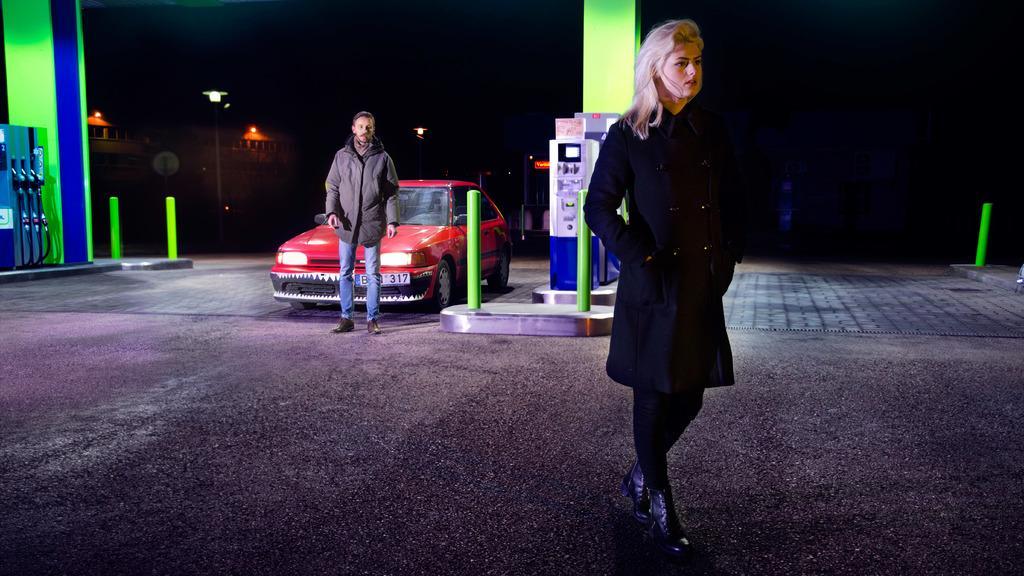Can you describe this image briefly? In this image we can see two person on the road, there is a car, few objects looks like petrol pump machines, pillars, rods, buildings, light pole and a dark background. 